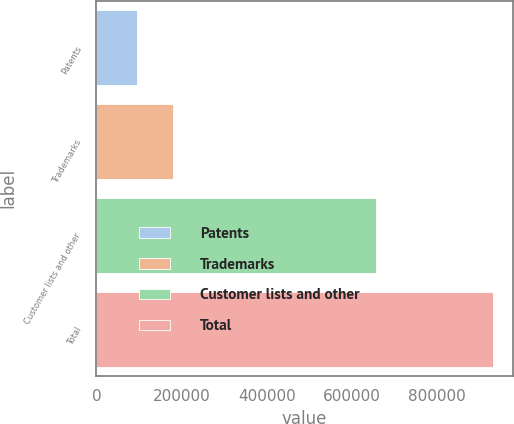Convert chart. <chart><loc_0><loc_0><loc_500><loc_500><bar_chart><fcel>Patents<fcel>Trademarks<fcel>Customer lists and other<fcel>Total<nl><fcel>95961<fcel>179532<fcel>656552<fcel>931669<nl></chart> 